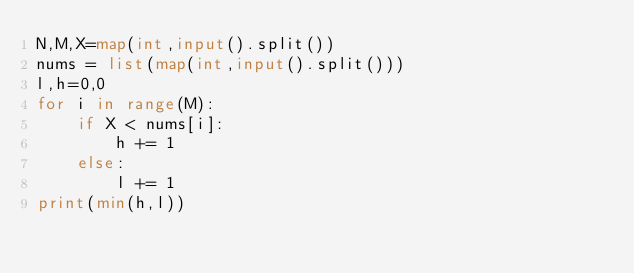<code> <loc_0><loc_0><loc_500><loc_500><_Python_>N,M,X=map(int,input().split())
nums = list(map(int,input().split()))
l,h=0,0
for i in range(M):
    if X < nums[i]:
        h += 1
    else:
        l += 1
print(min(h,l))</code> 